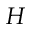<formula> <loc_0><loc_0><loc_500><loc_500>H</formula> 